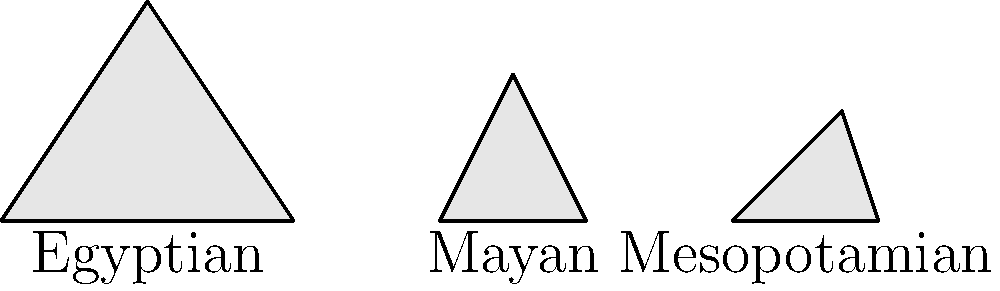Consider the architectural designs of ancient pyramids and ziggurats from isolated civilizations shown above. Despite the apparent similarities in their triangular shapes, how would you argue that these structures developed independently rather than through cultural diffusion? Analyze the specific geometric properties and cultural contexts of each design to support your argument. To argue that these structures developed independently rather than through cultural diffusion, we can consider the following points:

1. Geometric differences:
   a) The Egyptian pyramid has a perfect triangular shape with a sharp point at the top.
   b) The Mayan pyramid has a slightly different angle and often included a flat top for ceremonial purposes.
   c) The Mesopotamian ziggurat has a stepped design with multiple levels.

2. Cultural context:
   a) Egyptian pyramids were built as tombs for pharaohs, reflecting their belief in the afterlife.
   b) Mayan pyramids served as temples for religious ceremonies and astronomical observations.
   c) Mesopotamian ziggurats were considered homes for the gods and used for worship.

3. Time periods:
   These structures were built in different time periods, with significant gaps between their constructions, making direct cultural exchange unlikely.

4. Geographic isolation:
   The vast distances between these civilizations (Egypt, Mesoamerica, and Mesopotamia) made significant cultural exchange improbable during ancient times.

5. Mathematical knowledge:
   Each civilization likely developed its own mathematical and engineering techniques to create these structures, based on local resources and needs.

6. Symbolism:
   The triangular or stepped shape might represent a universal human concept of reaching towards the sky or the gods, which could have developed independently in each culture.

7. Functional similarities:
   The similar shapes could be attributed to the practical requirements of building tall, stable structures with ancient technologies, rather than cultural exchange.

By emphasizing these points, one can argue that despite superficial similarities, these structures developed independently as a result of each civilization's unique cultural, religious, and technological context, rather than through cultural diffusion.
Answer: Independent development due to unique cultural contexts and practical engineering constraints 